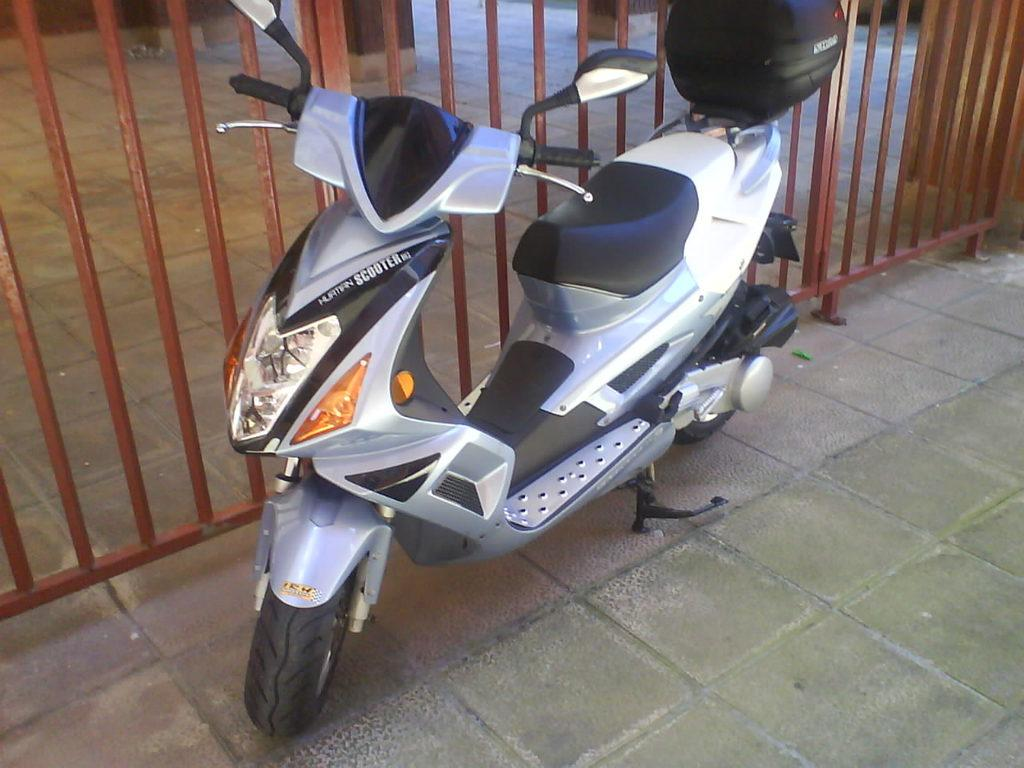What type of vehicle is in the image? There is a moped bike in the image. What color is the moped bike? The moped bike is gray in color. Where is the moped bike located in the image? The moped bike is parked on a tile path. What other object can be seen in the image? There is a railing in the image. What color is the railing? The railing is brown in color. What type of cake is being served on the moped bike in the image? There is no cake present in the image; it features a moped bike parked on a tile path with a brown railing. 